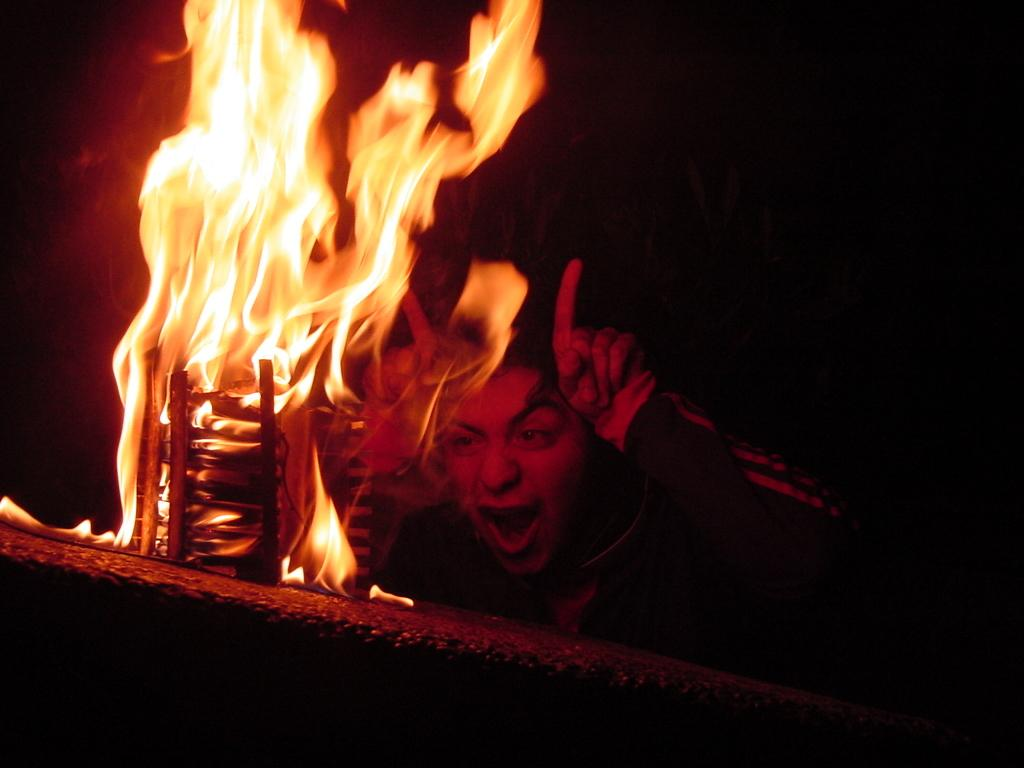What is present in the image? There is a person and a fire in the image. Can you describe the person in the image? Unfortunately, the provided facts do not give any details about the person's appearance or clothing. What is the nature of the fire in the image? The facts do not specify the type or size of the fire, only that it is present in the image. How many goldfish are swimming in the fire in the image? There are no goldfish present in the image, and the fire is not a body of water where fish could swim. 